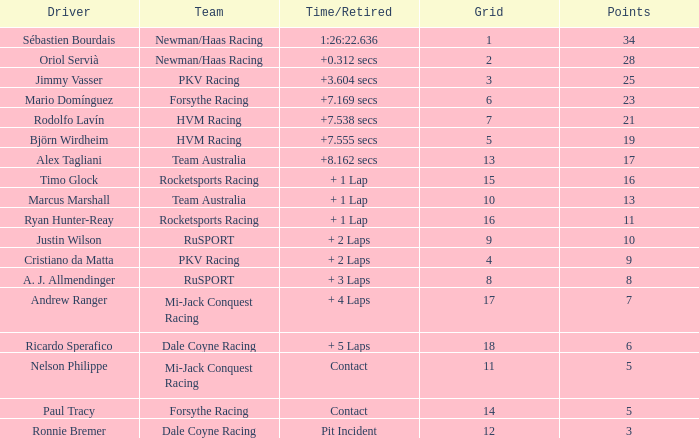Driver Ricardo Sperafico has what as his average laps? 161.0. 